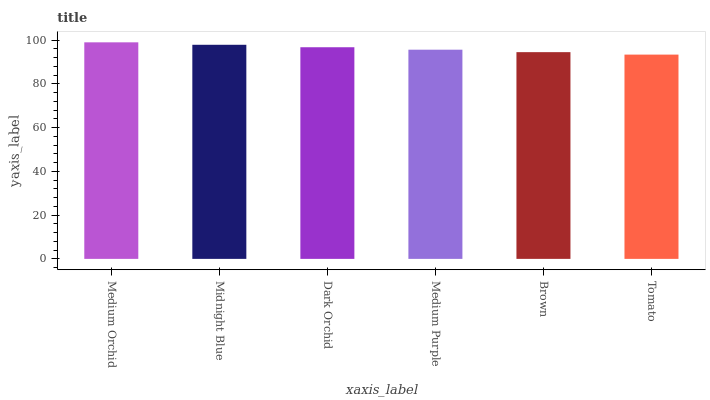Is Tomato the minimum?
Answer yes or no. Yes. Is Medium Orchid the maximum?
Answer yes or no. Yes. Is Midnight Blue the minimum?
Answer yes or no. No. Is Midnight Blue the maximum?
Answer yes or no. No. Is Medium Orchid greater than Midnight Blue?
Answer yes or no. Yes. Is Midnight Blue less than Medium Orchid?
Answer yes or no. Yes. Is Midnight Blue greater than Medium Orchid?
Answer yes or no. No. Is Medium Orchid less than Midnight Blue?
Answer yes or no. No. Is Dark Orchid the high median?
Answer yes or no. Yes. Is Medium Purple the low median?
Answer yes or no. Yes. Is Brown the high median?
Answer yes or no. No. Is Midnight Blue the low median?
Answer yes or no. No. 